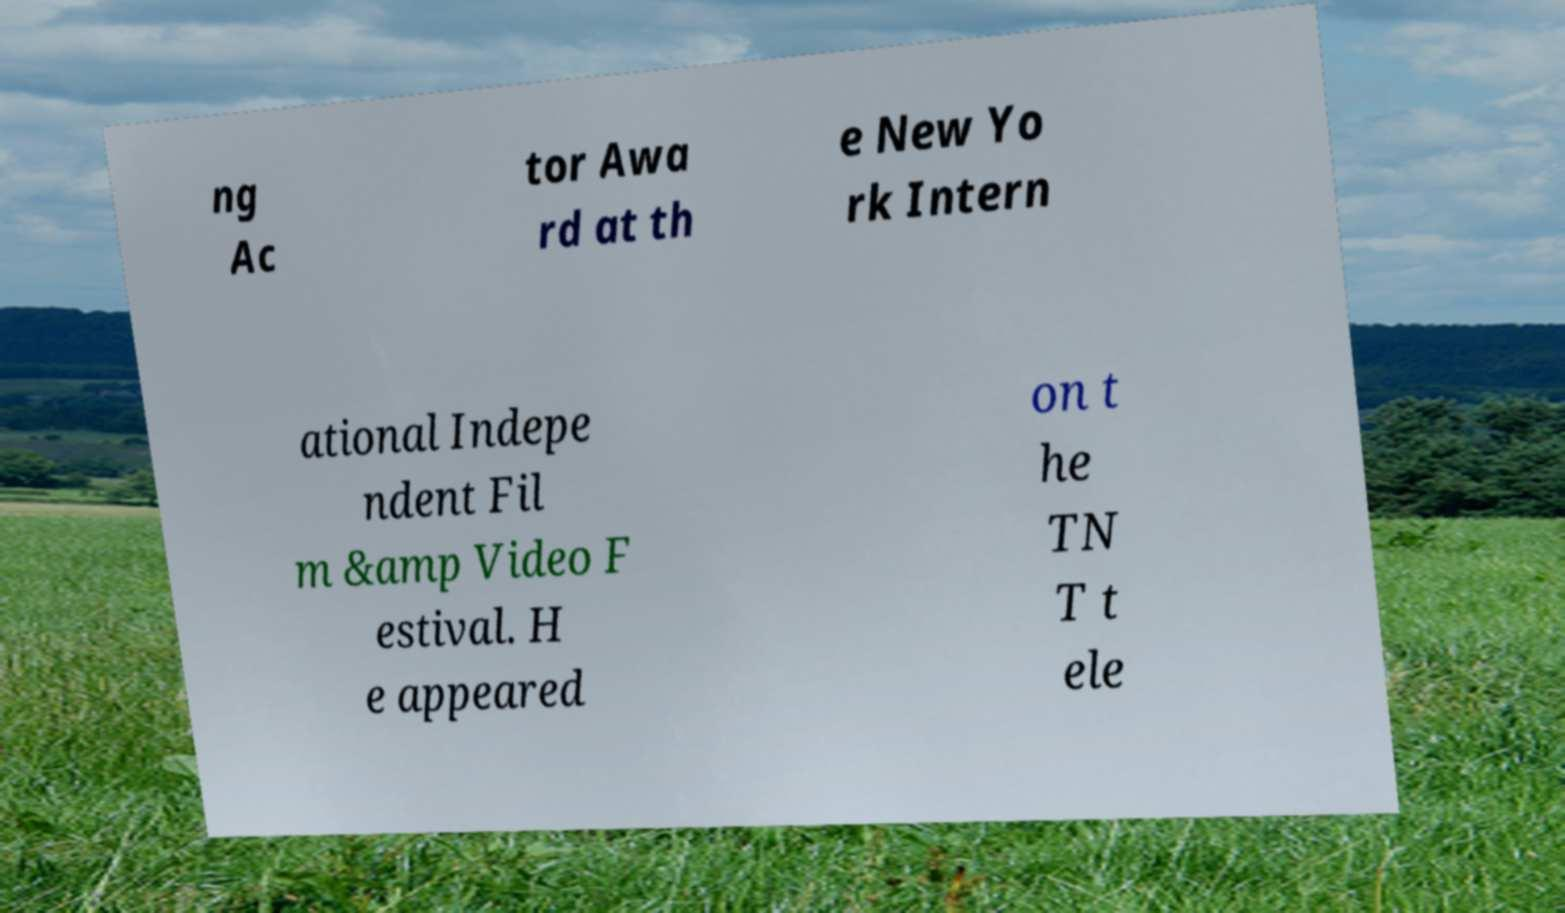I need the written content from this picture converted into text. Can you do that? ng Ac tor Awa rd at th e New Yo rk Intern ational Indepe ndent Fil m &amp Video F estival. H e appeared on t he TN T t ele 